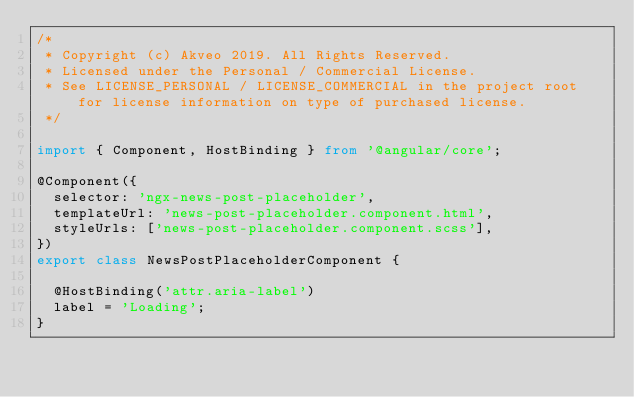<code> <loc_0><loc_0><loc_500><loc_500><_TypeScript_>/*
 * Copyright (c) Akveo 2019. All Rights Reserved.
 * Licensed under the Personal / Commercial License.
 * See LICENSE_PERSONAL / LICENSE_COMMERCIAL in the project root for license information on type of purchased license.
 */

import { Component, HostBinding } from '@angular/core';

@Component({
  selector: 'ngx-news-post-placeholder',
  templateUrl: 'news-post-placeholder.component.html',
  styleUrls: ['news-post-placeholder.component.scss'],
})
export class NewsPostPlaceholderComponent {

  @HostBinding('attr.aria-label')
  label = 'Loading';
}
</code> 